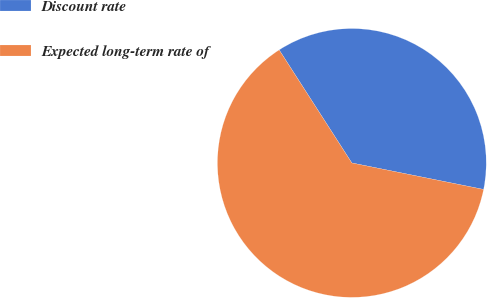Convert chart. <chart><loc_0><loc_0><loc_500><loc_500><pie_chart><fcel>Discount rate<fcel>Expected long-term rate of<nl><fcel>37.25%<fcel>62.75%<nl></chart> 